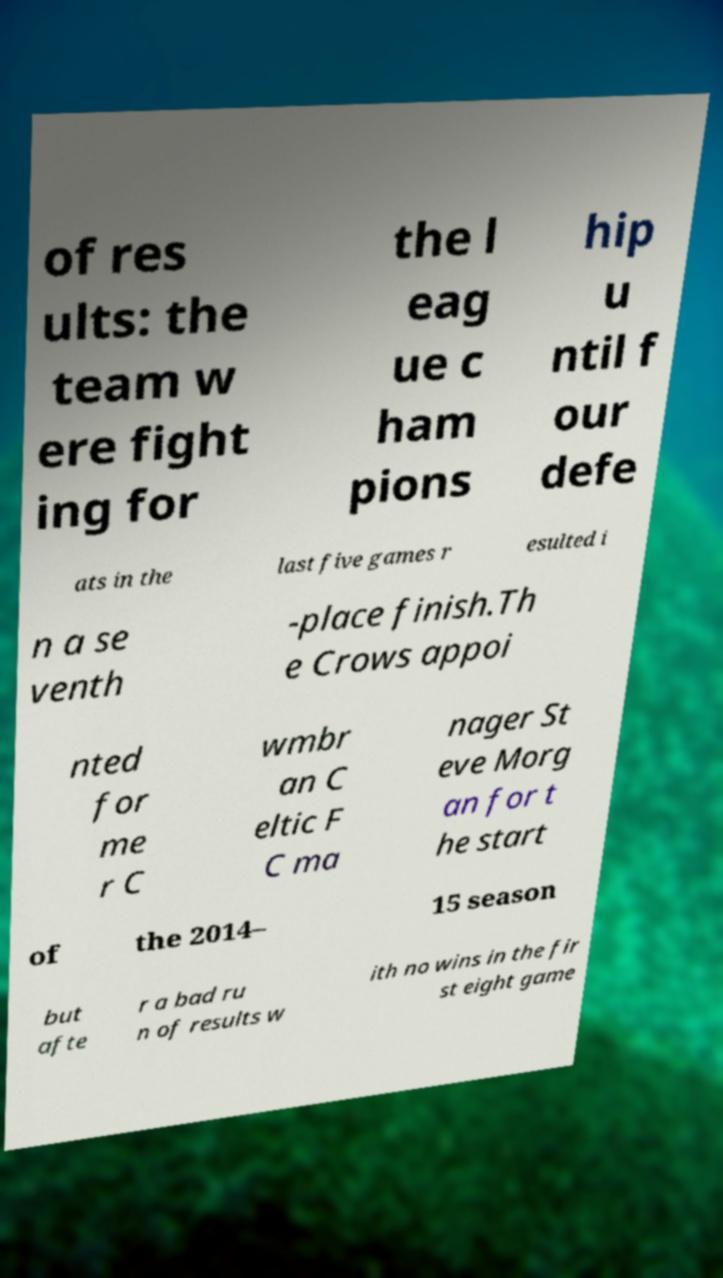I need the written content from this picture converted into text. Can you do that? of res ults: the team w ere fight ing for the l eag ue c ham pions hip u ntil f our defe ats in the last five games r esulted i n a se venth -place finish.Th e Crows appoi nted for me r C wmbr an C eltic F C ma nager St eve Morg an for t he start of the 2014– 15 season but afte r a bad ru n of results w ith no wins in the fir st eight game 